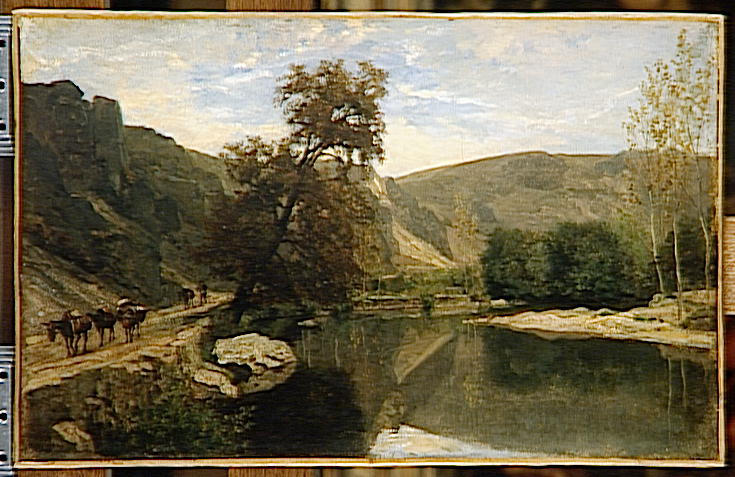Can you explain the significance of the rocky landscape in this artwork? The rocky landscape serves several artistic and thematic purposes. Artistically, it provides a rugged contrast to the soft fluidity of the water and sky, adding textural diversity that enriches the visual experience. Thematically, the rocks symbolize enduring strength and resilience amidst the serene and transient elements like water and clouds. They anchor the composition, giving a grounded, enduring quality to the scene that suggests a timeless connection to nature. 